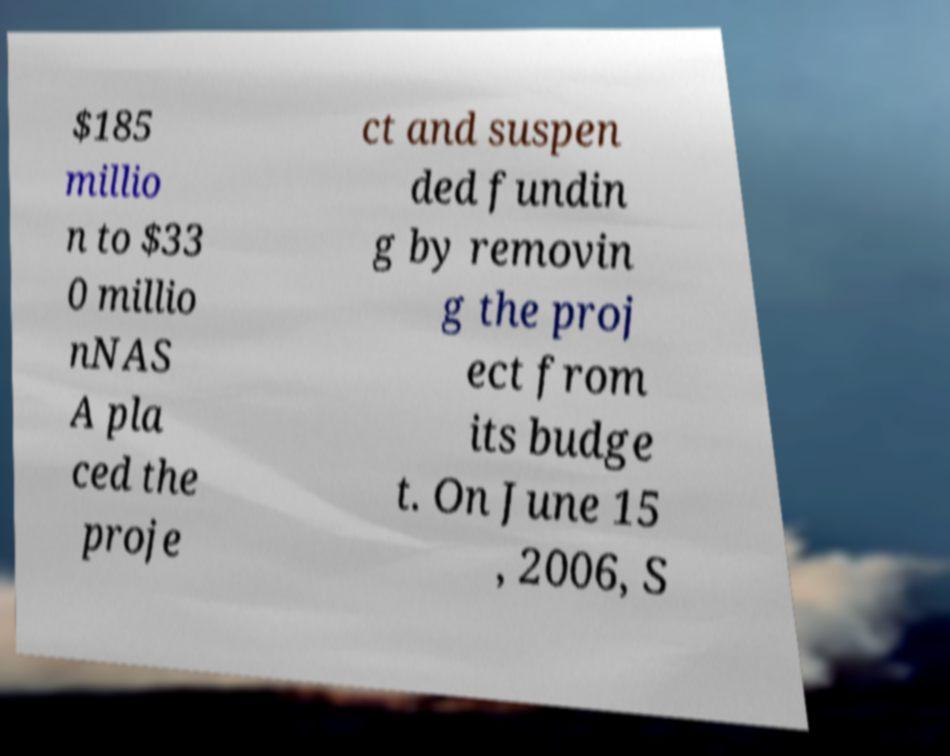For documentation purposes, I need the text within this image transcribed. Could you provide that? $185 millio n to $33 0 millio nNAS A pla ced the proje ct and suspen ded fundin g by removin g the proj ect from its budge t. On June 15 , 2006, S 